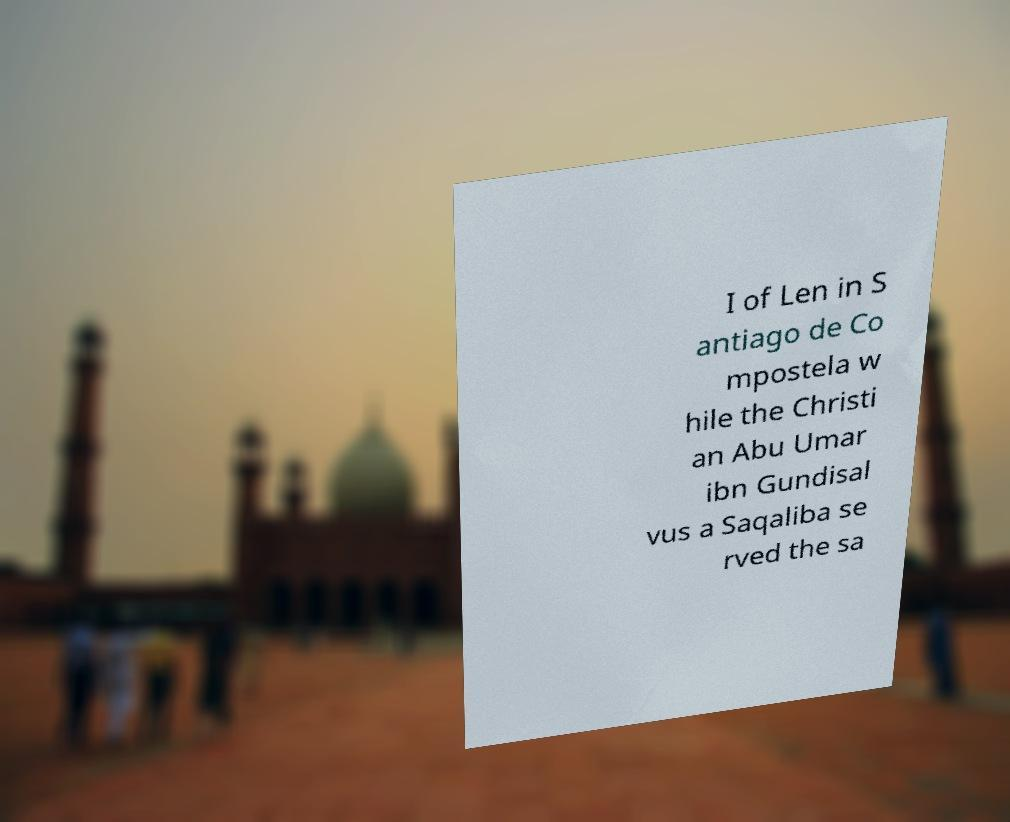There's text embedded in this image that I need extracted. Can you transcribe it verbatim? I of Len in S antiago de Co mpostela w hile the Christi an Abu Umar ibn Gundisal vus a Saqaliba se rved the sa 